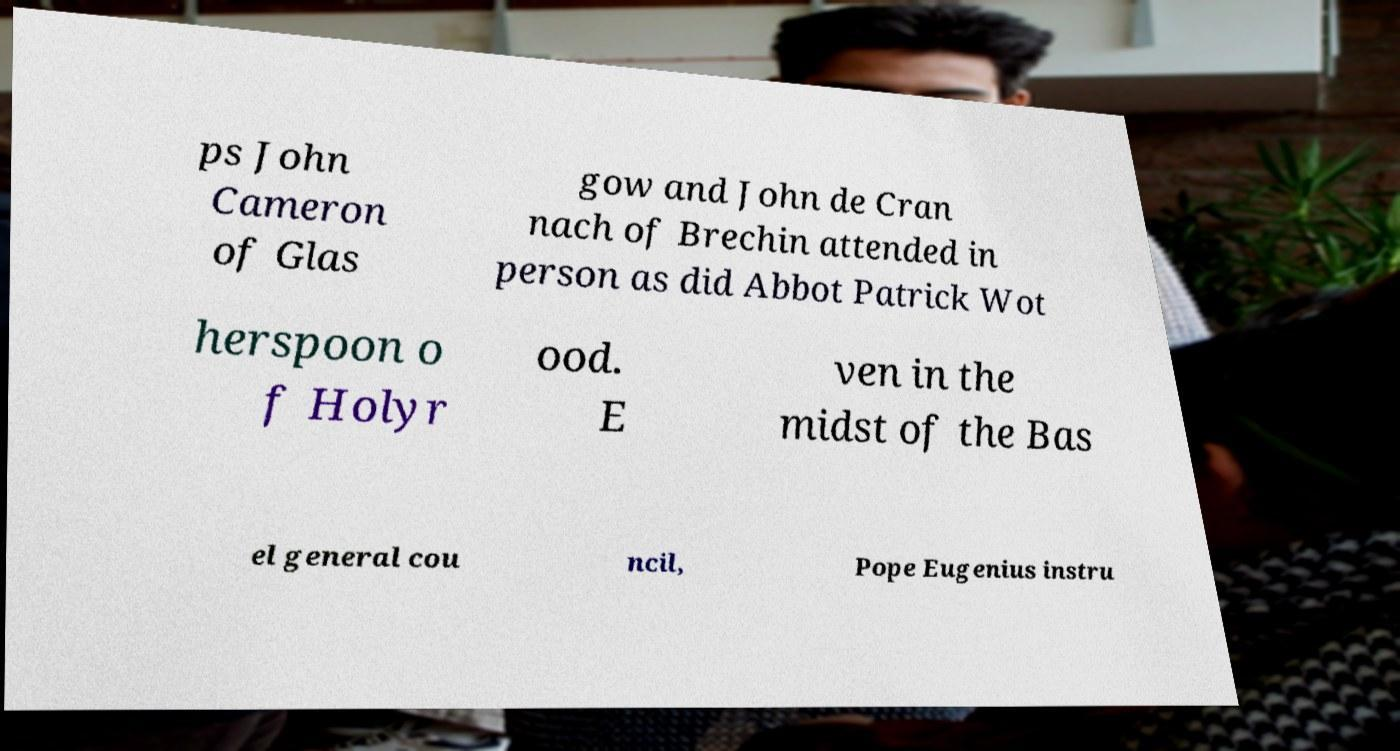I need the written content from this picture converted into text. Can you do that? ps John Cameron of Glas gow and John de Cran nach of Brechin attended in person as did Abbot Patrick Wot herspoon o f Holyr ood. E ven in the midst of the Bas el general cou ncil, Pope Eugenius instru 